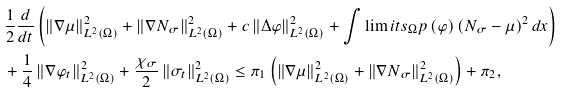<formula> <loc_0><loc_0><loc_500><loc_500>& \frac { 1 } { 2 } \frac { d } { d t } \left ( \left \| \nabla \mu \right \| _ { L ^ { 2 } \left ( \Omega \right ) } ^ { 2 } + \left \| \nabla N _ { \sigma } \right \| _ { L ^ { 2 } \left ( \Omega \right ) } ^ { 2 } + c \left \| \Delta \varphi \right \| _ { L ^ { 2 } \left ( \Omega \right ) } ^ { 2 } + \int \lim i t s _ { \Omega } p \left ( \varphi \right ) \left ( N _ { \sigma } - \mu \right ) ^ { 2 } d x \right ) \\ & + \frac { 1 } { 4 } \left \| \nabla \varphi _ { t } \right \| _ { L ^ { 2 } \left ( \Omega \right ) } ^ { 2 } + \frac { \chi _ { \sigma } } { 2 } \left \| \sigma _ { t } \right \| _ { L ^ { 2 } \left ( \Omega \right ) } ^ { 2 } \leq \pi _ { 1 } \left ( \left \| \nabla \mu \right \| _ { L ^ { 2 } \left ( \Omega \right ) } ^ { 2 } + \left \| \nabla N _ { \sigma } \right \| _ { L ^ { 2 } \left ( \Omega \right ) } ^ { 2 } \right ) + \pi _ { 2 } ,</formula> 